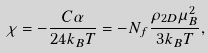<formula> <loc_0><loc_0><loc_500><loc_500>\chi = - \frac { C \alpha } { 2 4 k _ { B } T } = - N _ { f } \frac { \rho _ { 2 D } \mu _ { B } ^ { 2 } } { 3 k _ { B } T } ,</formula> 